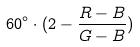<formula> <loc_0><loc_0><loc_500><loc_500>6 0 ^ { \circ } \cdot ( 2 - \frac { R - B } { G - B } )</formula> 